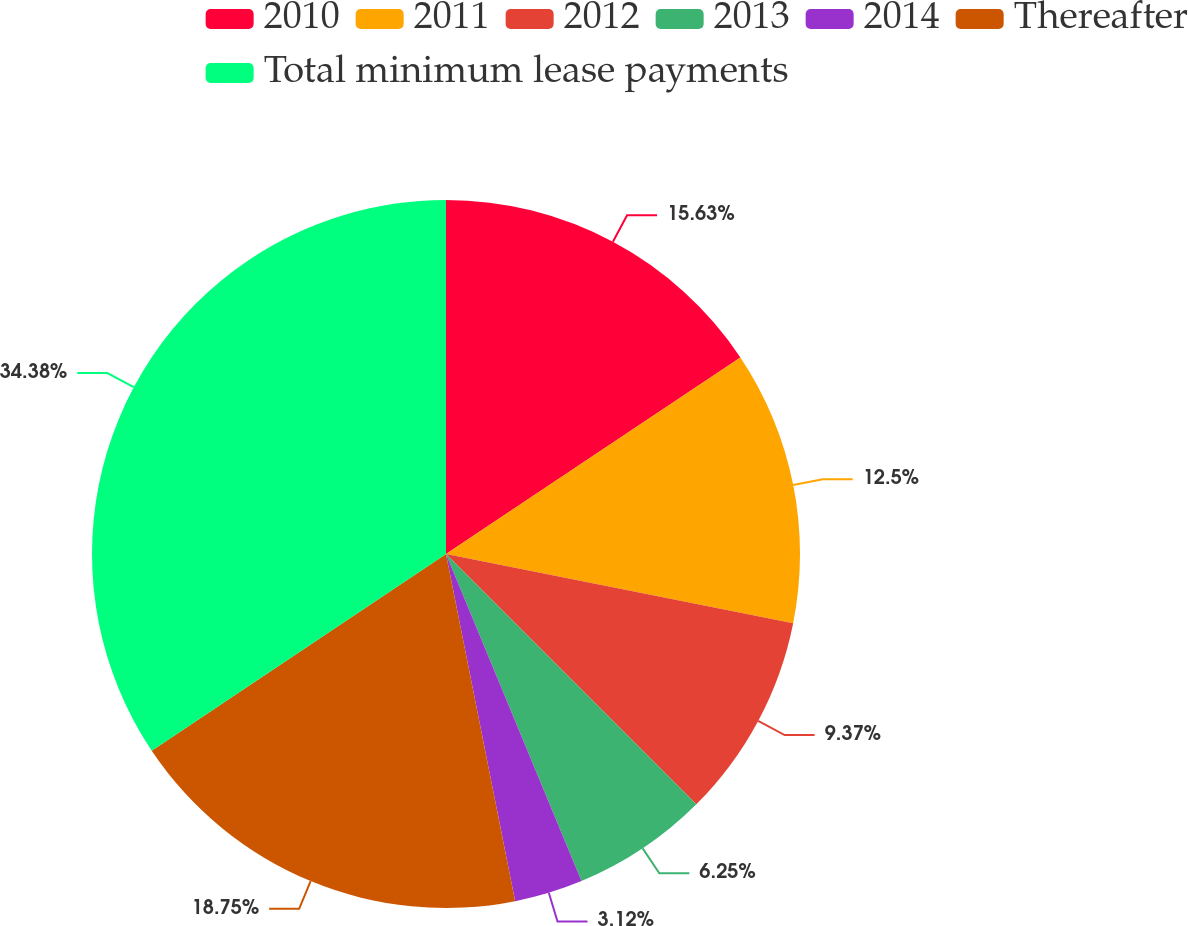Convert chart. <chart><loc_0><loc_0><loc_500><loc_500><pie_chart><fcel>2010<fcel>2011<fcel>2012<fcel>2013<fcel>2014<fcel>Thereafter<fcel>Total minimum lease payments<nl><fcel>15.63%<fcel>12.5%<fcel>9.37%<fcel>6.25%<fcel>3.12%<fcel>18.75%<fcel>34.38%<nl></chart> 